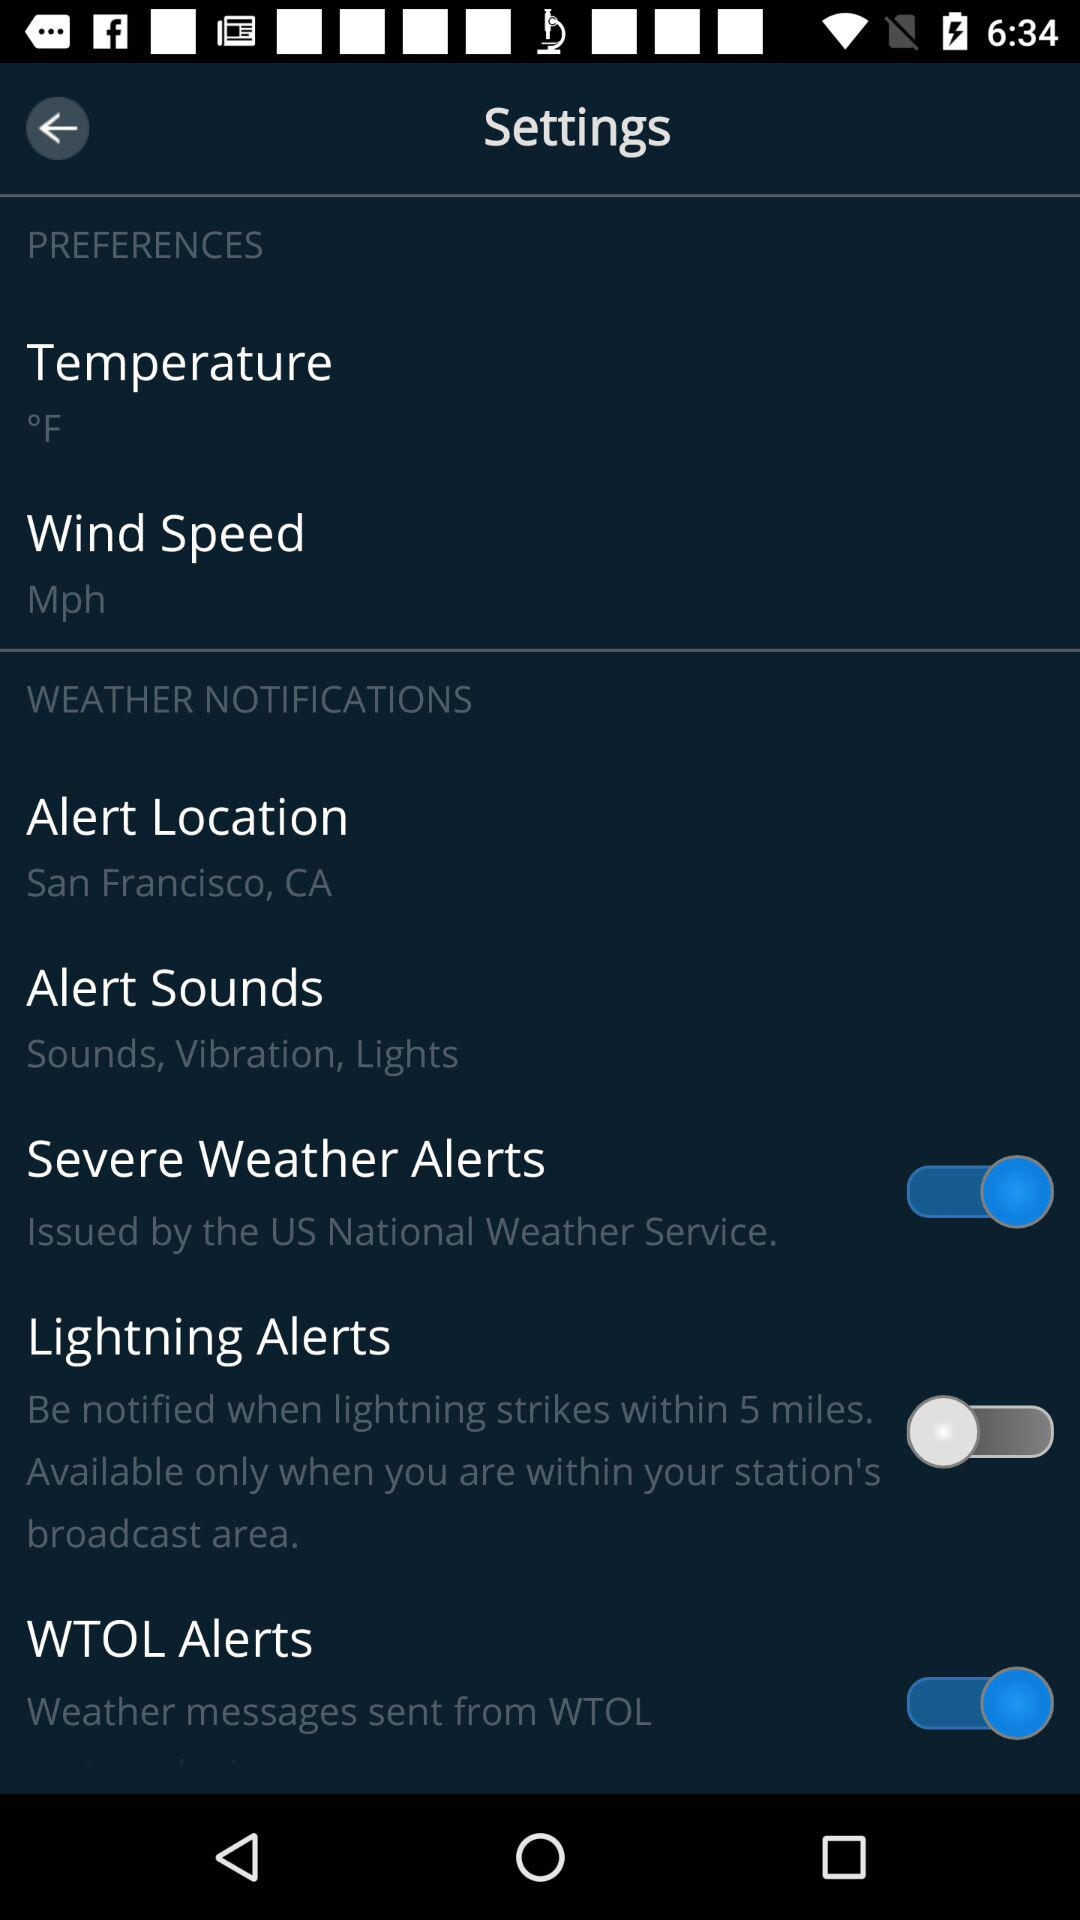What is the status of "Lightning Alerts"? The status is "off". 